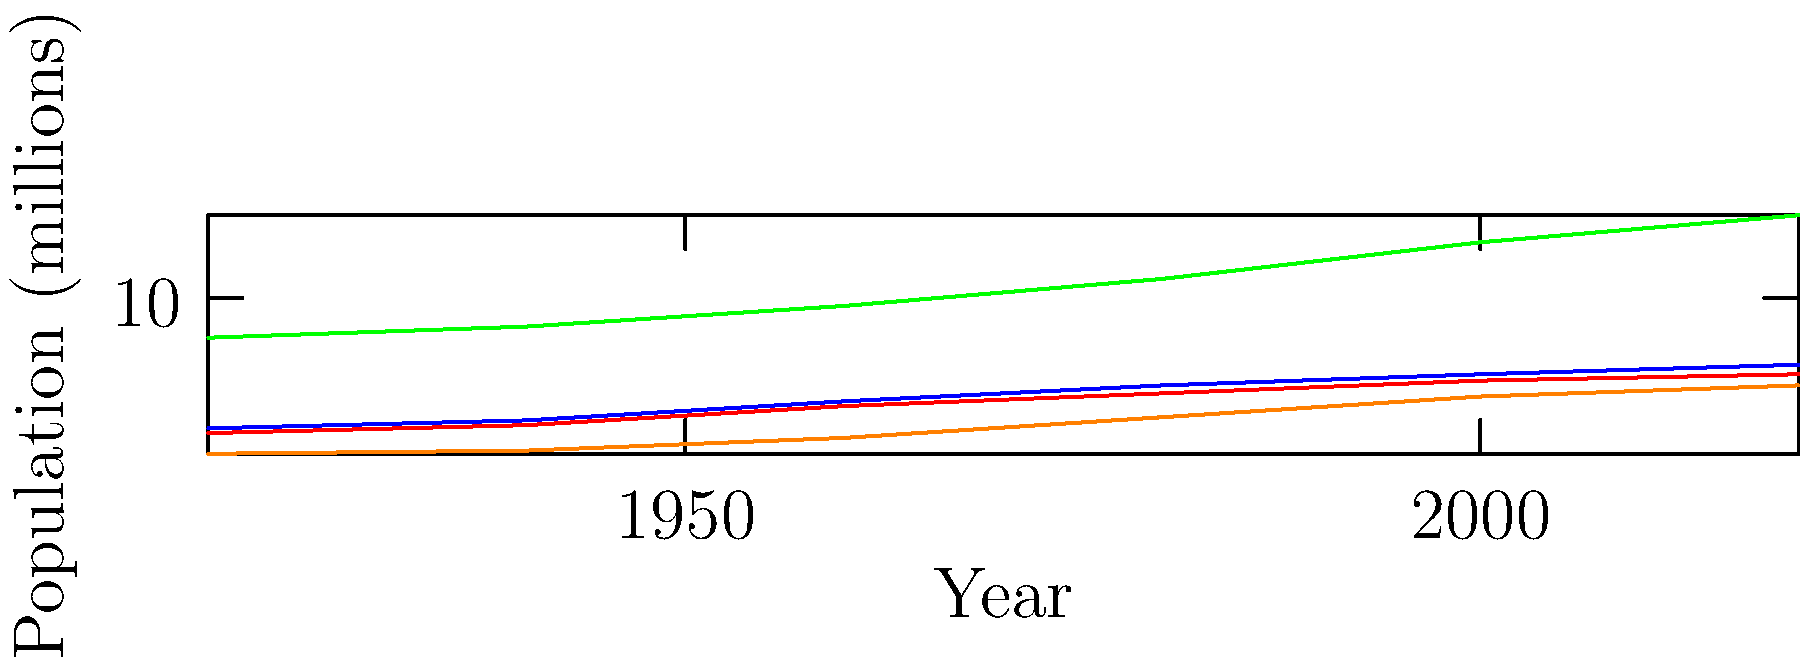Based on the line graph showing African American population growth in different regions of the United States from 1920 to 2020, which region experienced the most significant absolute increase in African American population, and what factors might have contributed to this trend? To answer this question, we need to analyze the graph and consider historical context:

1. Observe the lines for each region:
   - Northeast (blue): Gradual increase from 1.8 to 5.8 million
   - Midwest (red): Gradual increase from 1.5 to 5.2 million
   - South (green): Steepest increase from 7.5 to 15.2 million
   - West (orange): Gradual increase from 0.2 to 4.5 million

2. Calculate the absolute increase for each region:
   - Northeast: 5.8 - 1.8 = 4.0 million
   - Midwest: 5.2 - 1.5 = 3.7 million
   - South: 15.2 - 7.5 = 7.7 million
   - West: 4.5 - 0.2 = 4.3 million

3. Identify the region with the largest absolute increase: The South, with 7.7 million.

4. Consider factors contributing to this trend:
   a) Historical context: The Great Migration (1916-1970) saw millions of African Americans move from the rural South to urban areas in the North, Midwest, and West.
   b) Reverse Migration: Since the 1970s, there has been a trend of African Americans moving back to the South, attracted by economic opportunities and cultural ties.
   c) Higher birth rates in the South compared to other regions.
   d) Improved civil rights and reduced racial discrimination in the South over time.
   e) Economic development in Southern cities, creating more job opportunities.

5. Conclusion: The South experienced the most significant absolute increase in African American population due to a combination of historical migration patterns, demographic trends, and socio-economic changes.
Answer: The South, with factors including the Great Migration, Reverse Migration, higher birth rates, improved civil rights, and economic development contributing to its growth. 